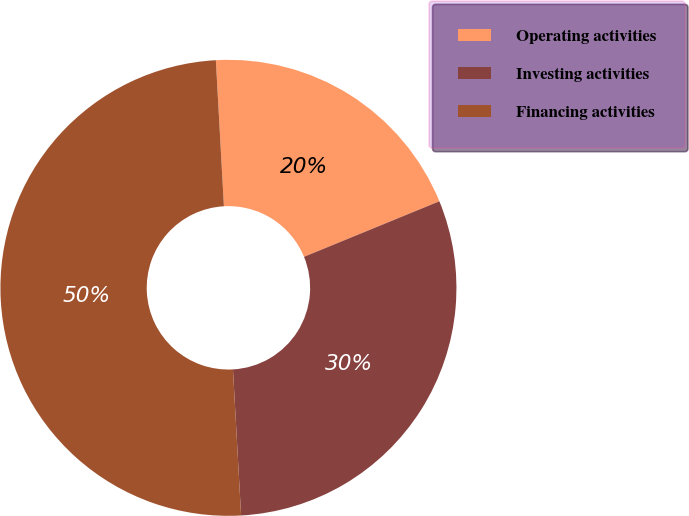<chart> <loc_0><loc_0><loc_500><loc_500><pie_chart><fcel>Operating activities<fcel>Investing activities<fcel>Financing activities<nl><fcel>19.68%<fcel>30.31%<fcel>50.0%<nl></chart> 